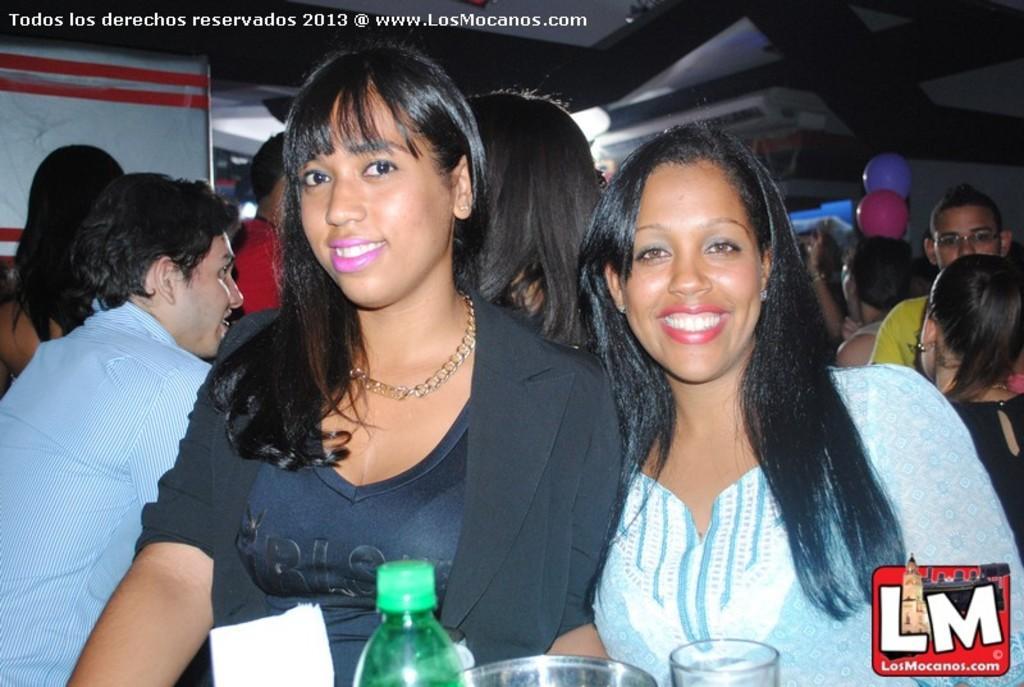In one or two sentences, can you explain what this image depicts? This picture describes about group of people, in the middle bottom of the image we can see bottle and glasses on the table, in the background we can find balloons. 